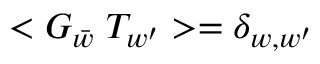<formula> <loc_0><loc_0><loc_500><loc_500>< G _ { \bar { w } } \, T _ { w ^ { \prime } } > = \delta _ { w , w ^ { \prime } }</formula> 